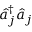Convert formula to latex. <formula><loc_0><loc_0><loc_500><loc_500>\hat { a } _ { j } ^ { \dagger } \hat { a } _ { j }</formula> 